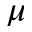Convert formula to latex. <formula><loc_0><loc_0><loc_500><loc_500>\mu</formula> 